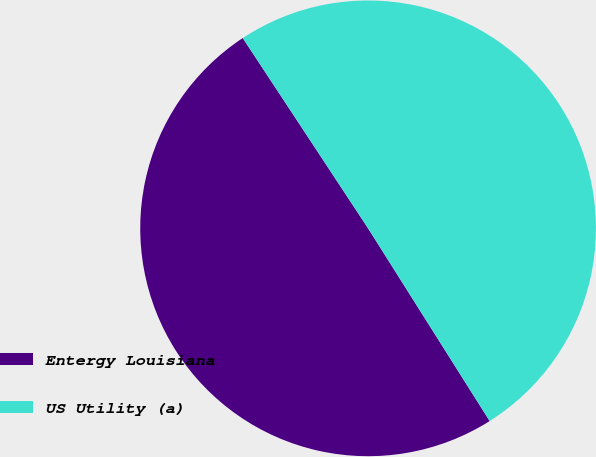<chart> <loc_0><loc_0><loc_500><loc_500><pie_chart><fcel>Entergy Louisiana<fcel>US Utility (a)<nl><fcel>49.69%<fcel>50.31%<nl></chart> 